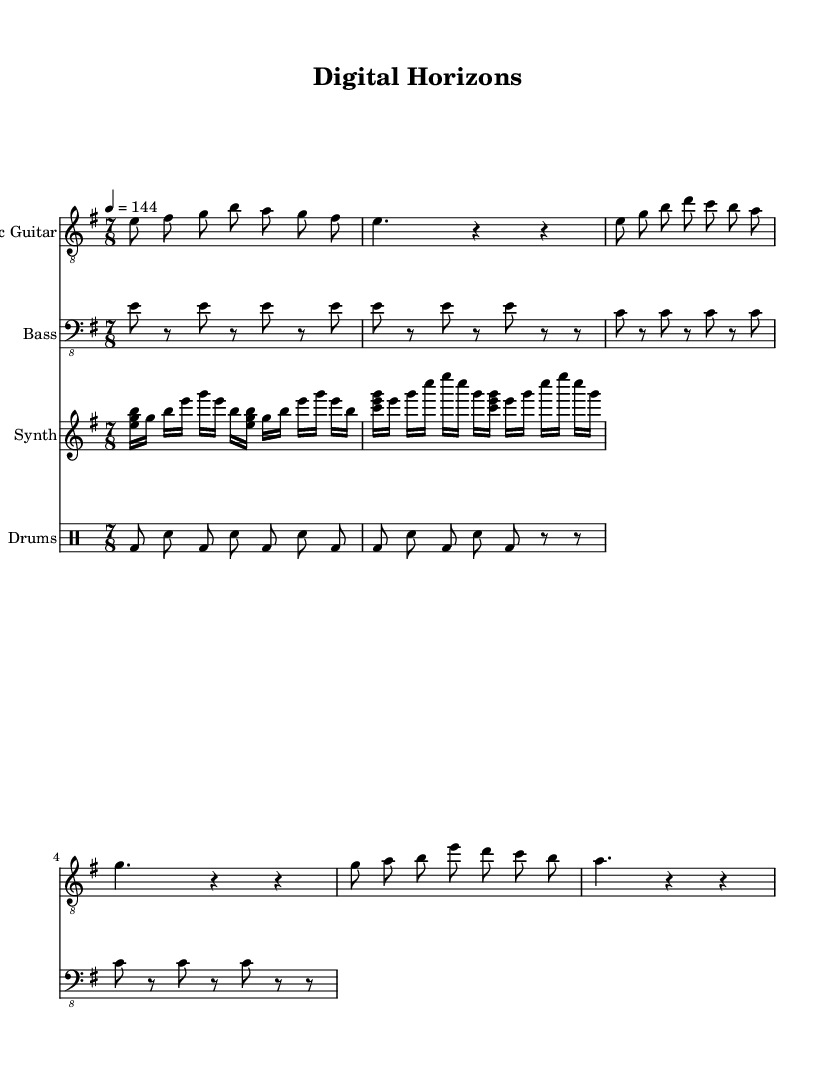What is the key signature of this music? The key signature shows that there are no sharps or flats, which indicates it is in E minor.
Answer: E minor What is the time signature of this piece? The time signature is indicated at the beginning of the score, showing 7/8, meaning there are seven eighth notes per measure.
Answer: 7/8 What is the tempo marking provided in the score? The tempo is specified in beats per minute, showing a marking of 4 equals 144, which means there are 144 beats in a minute.
Answer: 144 What rhythmic pattern does the bass guitar follow? By examining the bass line, it can be observed that it uses a syncopated rhythm primarily featuring rests interspersed with notes, particularly emphasizing the notes in a 7/8 pattern.
Answer: Syncopated How many measures are present in the introduction of the electric guitar? The introduction of the electric guitar consists of two measures, as indicated by the groupings of notes and rests in the arrangement provided.
Answer: 2 measures Which instrument plays arpeggiated patterns using chords? The synthesizer section contains repeated sequences of notes organized into chords that create an arpeggiated pattern, typical in keyboard parts.
Answer: Synthesizer What is the primary focus of the lyrical content typically associated with progressive rock, as hinted in this composition's title? The title "Digital Horizons" suggests a theme relating to technology and innovation, a common focus in progressive rock narratives, emphasizing exploration of the digital landscape.
Answer: Technological innovation 